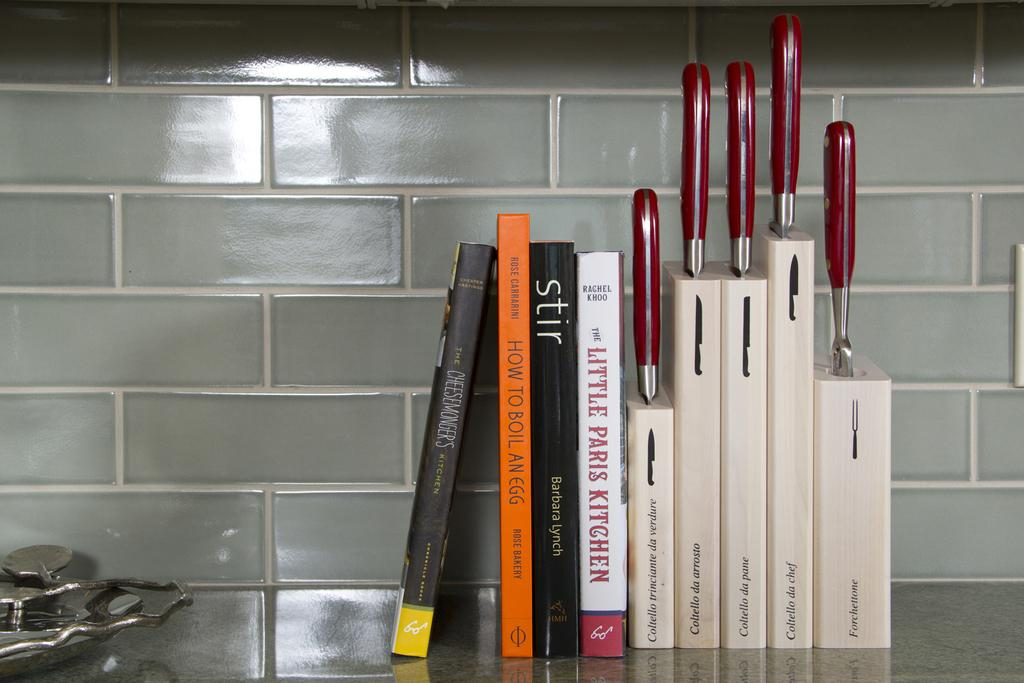<image>
Render a clear and concise summary of the photo. A group of books next to some knives including The Little Paris Kitchen. 